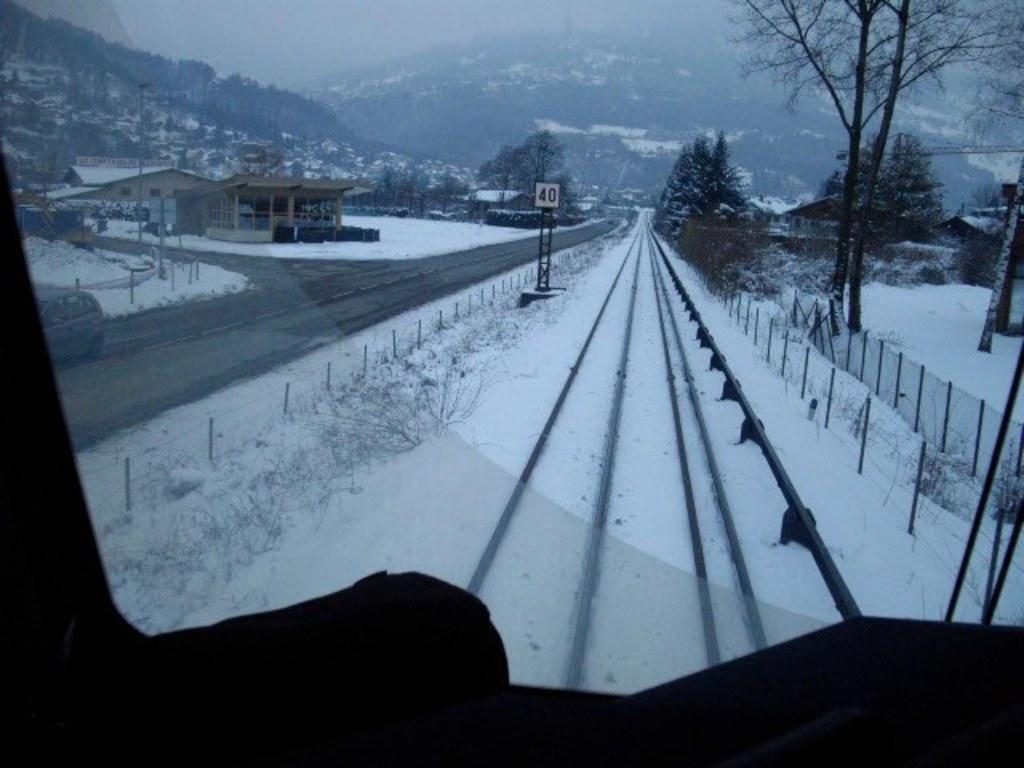Can you describe this image briefly? As we can see in the image there is railway track, snow, fence, buildings, trees, pole and hills. 